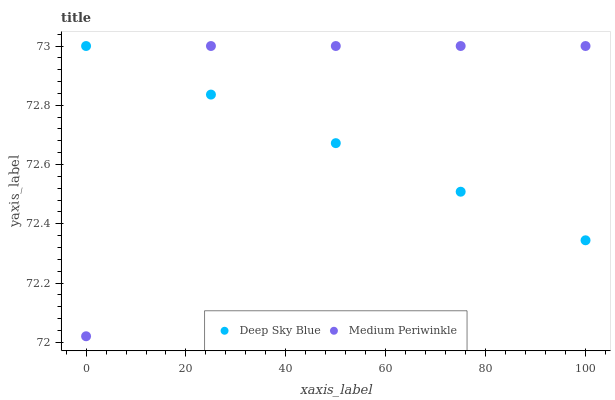Does Deep Sky Blue have the minimum area under the curve?
Answer yes or no. Yes. Does Medium Periwinkle have the maximum area under the curve?
Answer yes or no. Yes. Does Deep Sky Blue have the maximum area under the curve?
Answer yes or no. No. Is Deep Sky Blue the smoothest?
Answer yes or no. Yes. Is Medium Periwinkle the roughest?
Answer yes or no. Yes. Is Deep Sky Blue the roughest?
Answer yes or no. No. Does Medium Periwinkle have the lowest value?
Answer yes or no. Yes. Does Deep Sky Blue have the lowest value?
Answer yes or no. No. Does Deep Sky Blue have the highest value?
Answer yes or no. Yes. Does Deep Sky Blue intersect Medium Periwinkle?
Answer yes or no. Yes. Is Deep Sky Blue less than Medium Periwinkle?
Answer yes or no. No. Is Deep Sky Blue greater than Medium Periwinkle?
Answer yes or no. No. 